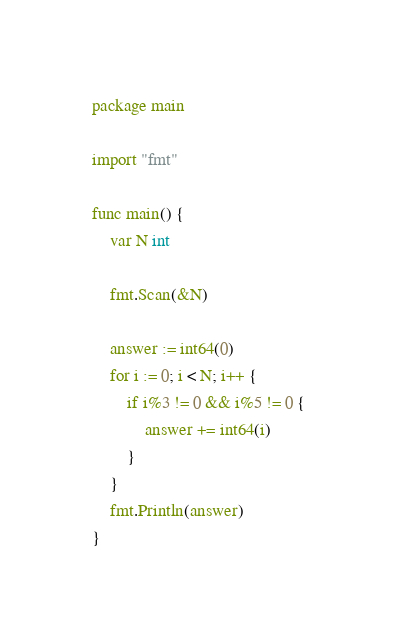Convert code to text. <code><loc_0><loc_0><loc_500><loc_500><_Go_>package main

import "fmt"

func main() {
	var N int

	fmt.Scan(&N)

	answer := int64(0)
	for i := 0; i < N; i++ {
		if i%3 != 0 && i%5 != 0 {
			answer += int64(i)
		}
	}
	fmt.Println(answer)
}
</code> 